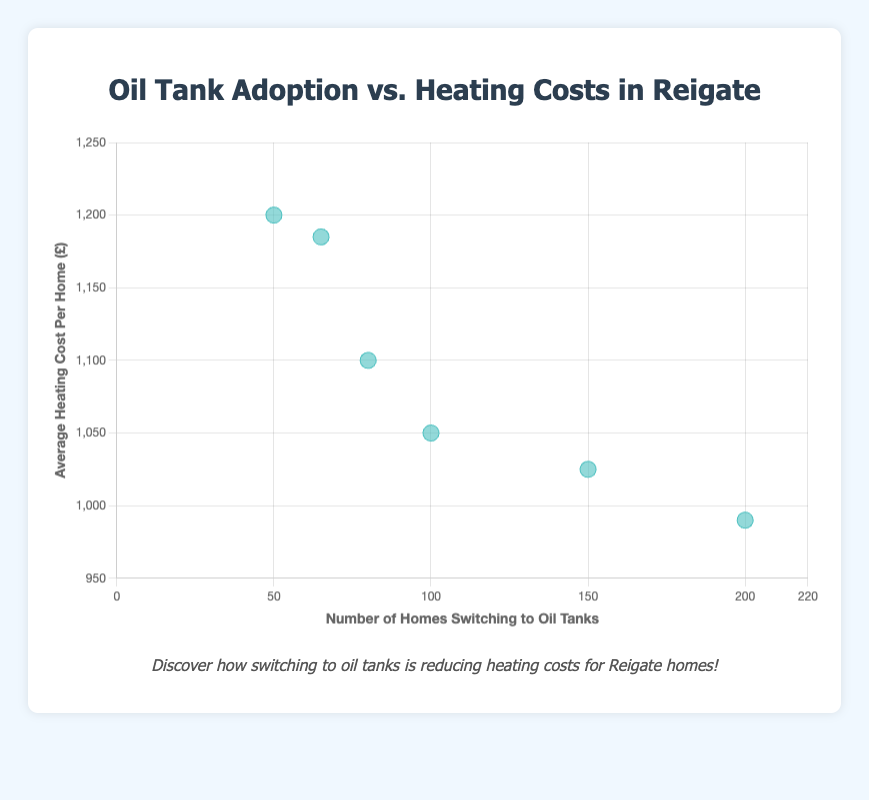How many homes switched to oil tanks in 2020? The scatter plot shows that each point represents the number of homes switching to oil tanks for each respective year. The point corresponding to 2020 is labeled on the x-axis and shows the number of homes as 80.
Answer: 80 What is the average heating cost per home in 2023? The scatter plot presents data points that show the heating costs corresponding to each number of homes switching to oil tanks. In 2023, the data point indicates that the average heating cost per home is £990.
Answer: £990 Is there a trend between the number of homes switching to oil tanks and the average heating cost per home? Observing the scatter plot, we can visualize a trend where as the number of homes switching to oil tanks increases, the average heating cost per home tends to decrease. This is supported by the trend line in the plot.
Answer: Yes, heating costs decrease as more homes switch Which year saw the highest number of homes switching to oil tanks? By examining the x-axis values for each point, it is clear that the point farthest to the right (with the highest x-value) corresponds to the year 2023, with 200 homes switching to oil tanks.
Answer: 2023 How much did the heating cost decrease from 2018 to 2023? In 2018, the average heating cost per home was £1200. By 2023, it decreased to £990. The difference is calculated as £1200 - £990 = £210.
Answer: £210 What's the average number of homes switching to oil tanks from 2018 to 2023? The number of homes switching to oil tanks each year are 50, 65, 80, 100, 150, and 200. Adding these together gives 645 homes. Dividing by the number of years (6) gives an average of 645/6 ≈ 107.5 homes per year.
Answer: 107.5 Which year had the smallest decline in heating cost per home when compared to the previous year? Looking at the data points: from 2018 to 2019 (1200 to 1185, decline of 15), from 2019 to 2020 (1185 to 1100, decline of 85), from 2020 to 2021 (1100 to 1050, decline of 50), from 2021 to 2022 (1050 to 1025, decline of 25), and from 2022 to 2023 (1025 to 990, decline of 35). The smallest decline is from 2018 to 2019 at 15.
Answer: 2019 What's the difference in the number of homes switching to oil tanks between 2021 and 2022? In 2021, the number of homes switching was 100, whereas in 2022 it was 150. The difference is 150 - 100 = 50.
Answer: 50 